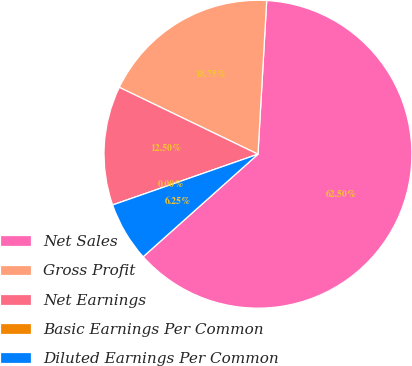<chart> <loc_0><loc_0><loc_500><loc_500><pie_chart><fcel>Net Sales<fcel>Gross Profit<fcel>Net Earnings<fcel>Basic Earnings Per Common<fcel>Diluted Earnings Per Common<nl><fcel>62.49%<fcel>18.75%<fcel>12.5%<fcel>0.0%<fcel>6.25%<nl></chart> 